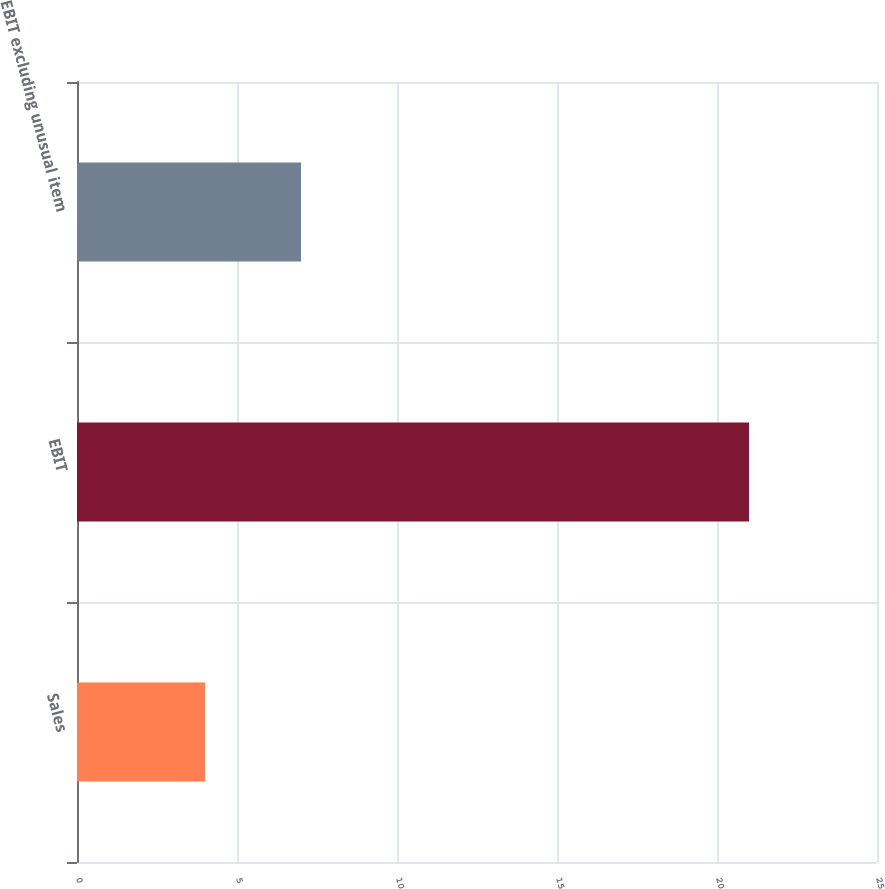Convert chart to OTSL. <chart><loc_0><loc_0><loc_500><loc_500><bar_chart><fcel>Sales<fcel>EBIT<fcel>EBIT excluding unusual item<nl><fcel>4<fcel>21<fcel>7<nl></chart> 